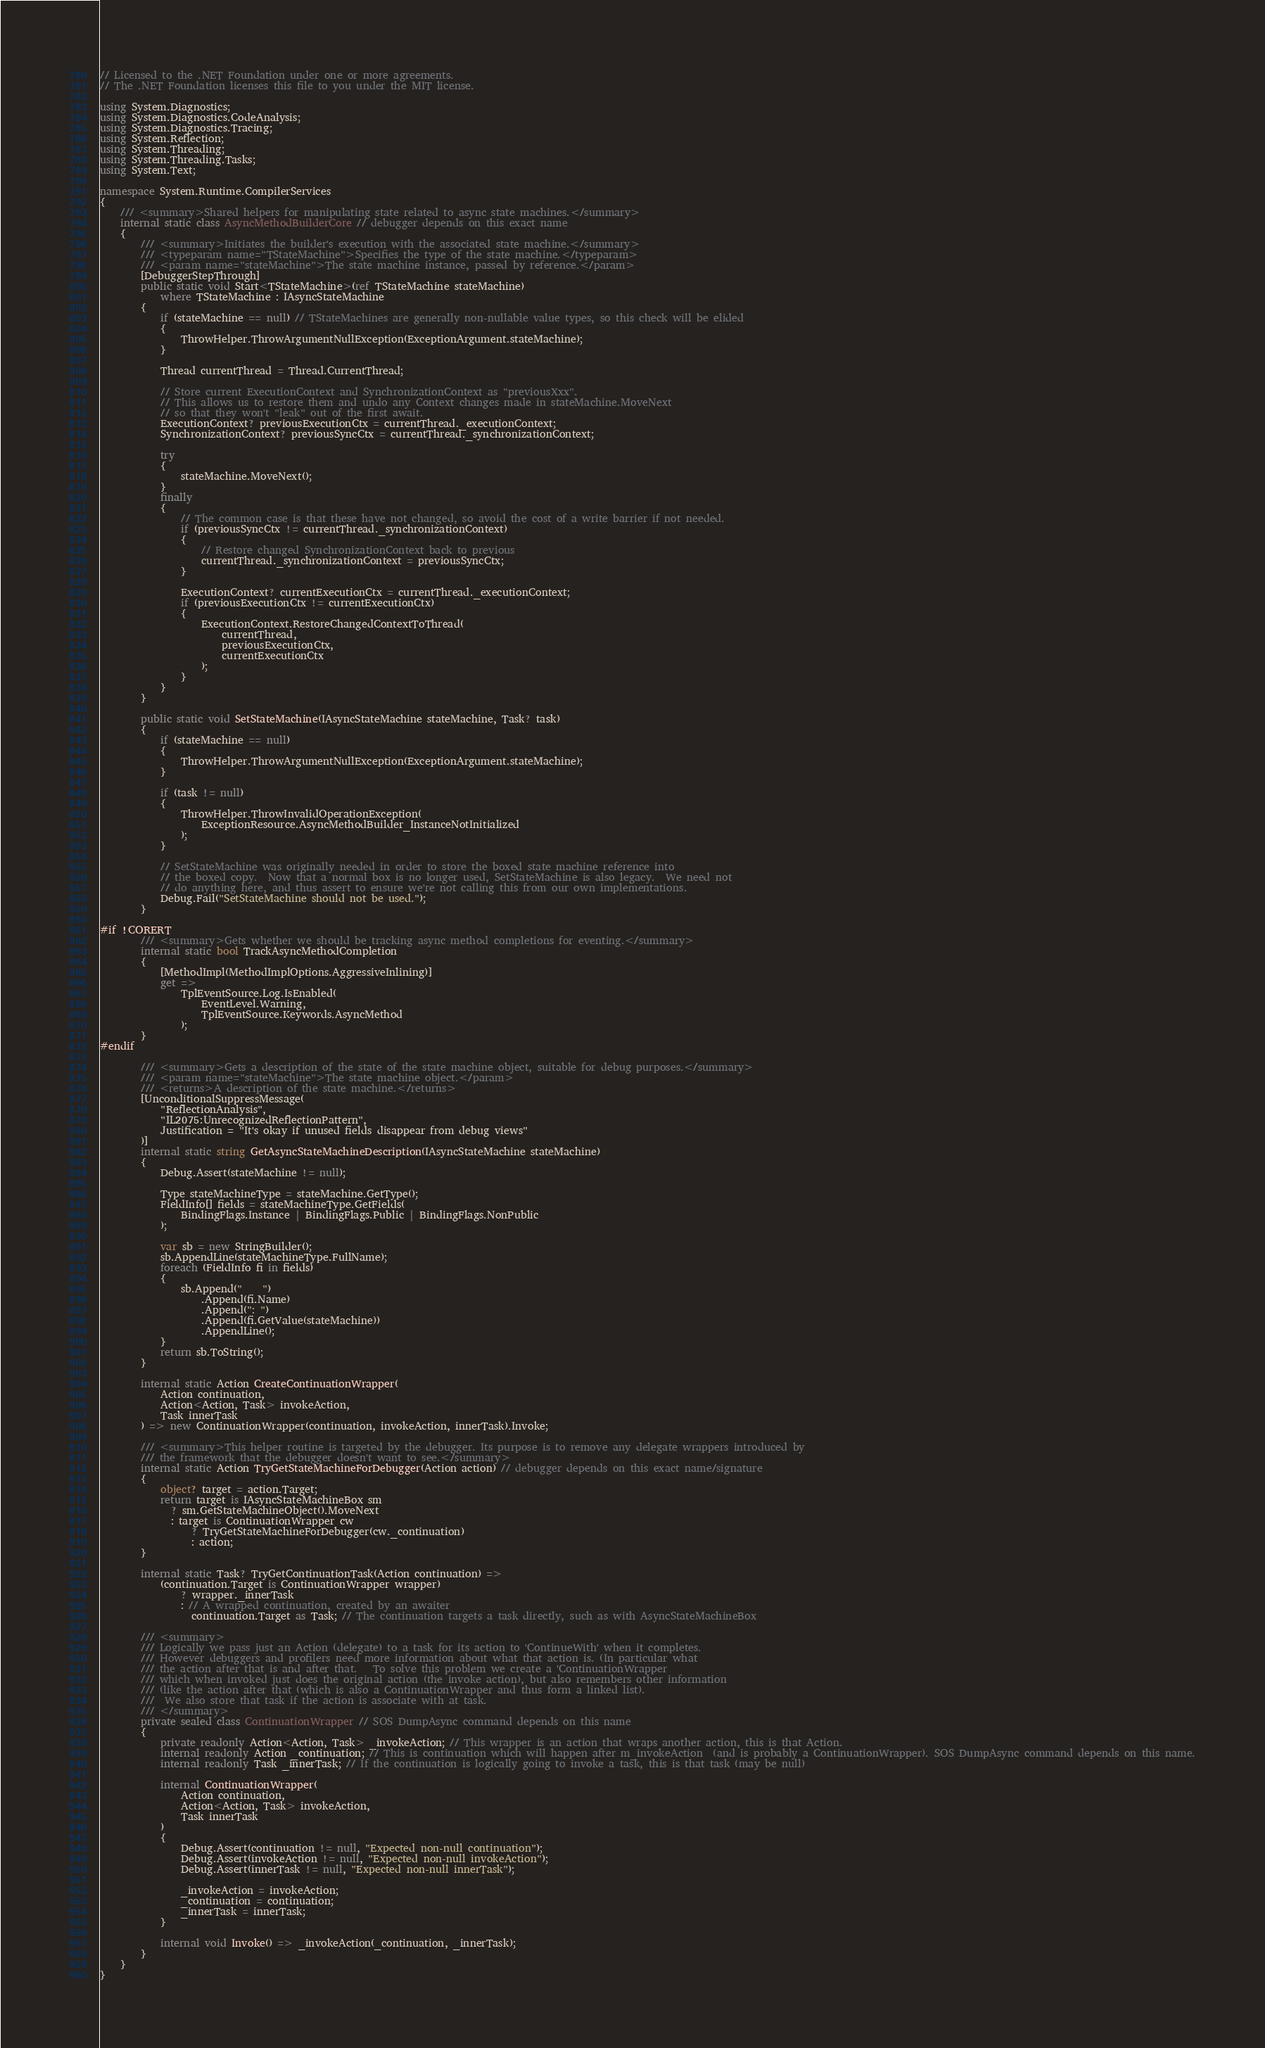Convert code to text. <code><loc_0><loc_0><loc_500><loc_500><_C#_>// Licensed to the .NET Foundation under one or more agreements.
// The .NET Foundation licenses this file to you under the MIT license.

using System.Diagnostics;
using System.Diagnostics.CodeAnalysis;
using System.Diagnostics.Tracing;
using System.Reflection;
using System.Threading;
using System.Threading.Tasks;
using System.Text;

namespace System.Runtime.CompilerServices
{
    /// <summary>Shared helpers for manipulating state related to async state machines.</summary>
    internal static class AsyncMethodBuilderCore // debugger depends on this exact name
    {
        /// <summary>Initiates the builder's execution with the associated state machine.</summary>
        /// <typeparam name="TStateMachine">Specifies the type of the state machine.</typeparam>
        /// <param name="stateMachine">The state machine instance, passed by reference.</param>
        [DebuggerStepThrough]
        public static void Start<TStateMachine>(ref TStateMachine stateMachine)
            where TStateMachine : IAsyncStateMachine
        {
            if (stateMachine == null) // TStateMachines are generally non-nullable value types, so this check will be elided
            {
                ThrowHelper.ThrowArgumentNullException(ExceptionArgument.stateMachine);
            }

            Thread currentThread = Thread.CurrentThread;

            // Store current ExecutionContext and SynchronizationContext as "previousXxx".
            // This allows us to restore them and undo any Context changes made in stateMachine.MoveNext
            // so that they won't "leak" out of the first await.
            ExecutionContext? previousExecutionCtx = currentThread._executionContext;
            SynchronizationContext? previousSyncCtx = currentThread._synchronizationContext;

            try
            {
                stateMachine.MoveNext();
            }
            finally
            {
                // The common case is that these have not changed, so avoid the cost of a write barrier if not needed.
                if (previousSyncCtx != currentThread._synchronizationContext)
                {
                    // Restore changed SynchronizationContext back to previous
                    currentThread._synchronizationContext = previousSyncCtx;
                }

                ExecutionContext? currentExecutionCtx = currentThread._executionContext;
                if (previousExecutionCtx != currentExecutionCtx)
                {
                    ExecutionContext.RestoreChangedContextToThread(
                        currentThread,
                        previousExecutionCtx,
                        currentExecutionCtx
                    );
                }
            }
        }

        public static void SetStateMachine(IAsyncStateMachine stateMachine, Task? task)
        {
            if (stateMachine == null)
            {
                ThrowHelper.ThrowArgumentNullException(ExceptionArgument.stateMachine);
            }

            if (task != null)
            {
                ThrowHelper.ThrowInvalidOperationException(
                    ExceptionResource.AsyncMethodBuilder_InstanceNotInitialized
                );
            }

            // SetStateMachine was originally needed in order to store the boxed state machine reference into
            // the boxed copy.  Now that a normal box is no longer used, SetStateMachine is also legacy.  We need not
            // do anything here, and thus assert to ensure we're not calling this from our own implementations.
            Debug.Fail("SetStateMachine should not be used.");
        }

#if !CORERT
        /// <summary>Gets whether we should be tracking async method completions for eventing.</summary>
        internal static bool TrackAsyncMethodCompletion
        {
            [MethodImpl(MethodImplOptions.AggressiveInlining)]
            get =>
                TplEventSource.Log.IsEnabled(
                    EventLevel.Warning,
                    TplEventSource.Keywords.AsyncMethod
                );
        }
#endif

        /// <summary>Gets a description of the state of the state machine object, suitable for debug purposes.</summary>
        /// <param name="stateMachine">The state machine object.</param>
        /// <returns>A description of the state machine.</returns>
        [UnconditionalSuppressMessage(
            "ReflectionAnalysis",
            "IL2075:UnrecognizedReflectionPattern",
            Justification = "It's okay if unused fields disappear from debug views"
        )]
        internal static string GetAsyncStateMachineDescription(IAsyncStateMachine stateMachine)
        {
            Debug.Assert(stateMachine != null);

            Type stateMachineType = stateMachine.GetType();
            FieldInfo[] fields = stateMachineType.GetFields(
                BindingFlags.Instance | BindingFlags.Public | BindingFlags.NonPublic
            );

            var sb = new StringBuilder();
            sb.AppendLine(stateMachineType.FullName);
            foreach (FieldInfo fi in fields)
            {
                sb.Append("    ")
                    .Append(fi.Name)
                    .Append(": ")
                    .Append(fi.GetValue(stateMachine))
                    .AppendLine();
            }
            return sb.ToString();
        }

        internal static Action CreateContinuationWrapper(
            Action continuation,
            Action<Action, Task> invokeAction,
            Task innerTask
        ) => new ContinuationWrapper(continuation, invokeAction, innerTask).Invoke;

        /// <summary>This helper routine is targeted by the debugger. Its purpose is to remove any delegate wrappers introduced by
        /// the framework that the debugger doesn't want to see.</summary>
        internal static Action TryGetStateMachineForDebugger(Action action) // debugger depends on this exact name/signature
        {
            object? target = action.Target;
            return target is IAsyncStateMachineBox sm
              ? sm.GetStateMachineObject().MoveNext
              : target is ContinuationWrapper cw
                  ? TryGetStateMachineForDebugger(cw._continuation)
                  : action;
        }

        internal static Task? TryGetContinuationTask(Action continuation) =>
            (continuation.Target is ContinuationWrapper wrapper)
                ? wrapper._innerTask
                : // A wrapped continuation, created by an awaiter
                  continuation.Target as Task; // The continuation targets a task directly, such as with AsyncStateMachineBox

        /// <summary>
        /// Logically we pass just an Action (delegate) to a task for its action to 'ContinueWith' when it completes.
        /// However debuggers and profilers need more information about what that action is. (In particular what
        /// the action after that is and after that.   To solve this problem we create a 'ContinuationWrapper
        /// which when invoked just does the original action (the invoke action), but also remembers other information
        /// (like the action after that (which is also a ContinuationWrapper and thus form a linked list).
        ///  We also store that task if the action is associate with at task.
        /// </summary>
        private sealed class ContinuationWrapper // SOS DumpAsync command depends on this name
        {
            private readonly Action<Action, Task> _invokeAction; // This wrapper is an action that wraps another action, this is that Action.
            internal readonly Action _continuation; // This is continuation which will happen after m_invokeAction  (and is probably a ContinuationWrapper). SOS DumpAsync command depends on this name.
            internal readonly Task _innerTask; // If the continuation is logically going to invoke a task, this is that task (may be null)

            internal ContinuationWrapper(
                Action continuation,
                Action<Action, Task> invokeAction,
                Task innerTask
            )
            {
                Debug.Assert(continuation != null, "Expected non-null continuation");
                Debug.Assert(invokeAction != null, "Expected non-null invokeAction");
                Debug.Assert(innerTask != null, "Expected non-null innerTask");

                _invokeAction = invokeAction;
                _continuation = continuation;
                _innerTask = innerTask;
            }

            internal void Invoke() => _invokeAction(_continuation, _innerTask);
        }
    }
}
</code> 